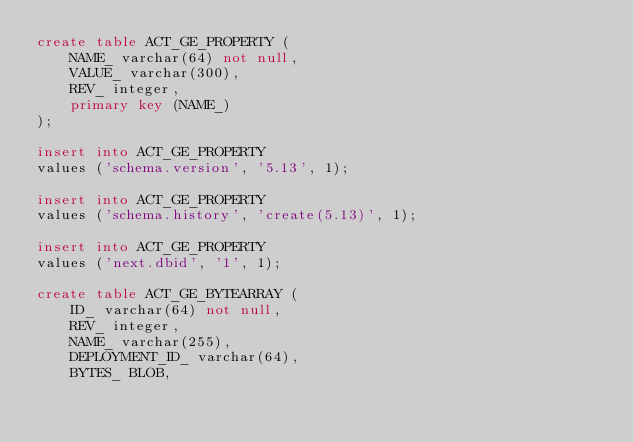<code> <loc_0><loc_0><loc_500><loc_500><_SQL_>create table ACT_GE_PROPERTY (
    NAME_ varchar(64) not null,
    VALUE_ varchar(300),
    REV_ integer,
    primary key (NAME_)
);

insert into ACT_GE_PROPERTY
values ('schema.version', '5.13', 1);

insert into ACT_GE_PROPERTY
values ('schema.history', 'create(5.13)', 1);

insert into ACT_GE_PROPERTY
values ('next.dbid', '1', 1);

create table ACT_GE_BYTEARRAY (
    ID_ varchar(64) not null,
    REV_ integer,
    NAME_ varchar(255),
    DEPLOYMENT_ID_ varchar(64),
    BYTES_ BLOB,</code> 